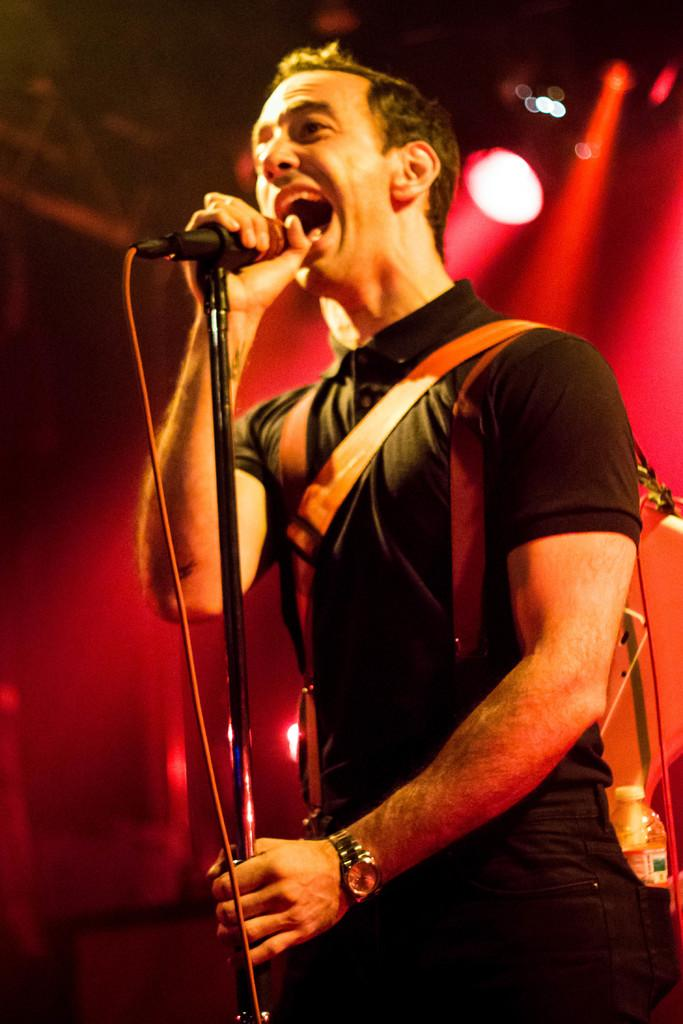What is the main subject in the foreground of the image? There is a man in the foreground of the image. What is the man holding in the image? The man is holding a mic and stand. What is the man wearing in the image? The man is wearing a guitar. What color light can be seen in the background of the image? There is a red light in the background of the image. What type of button is being pushed by the man in the image? There is no button being pushed by the man in the image; he is holding a mic and stand. 